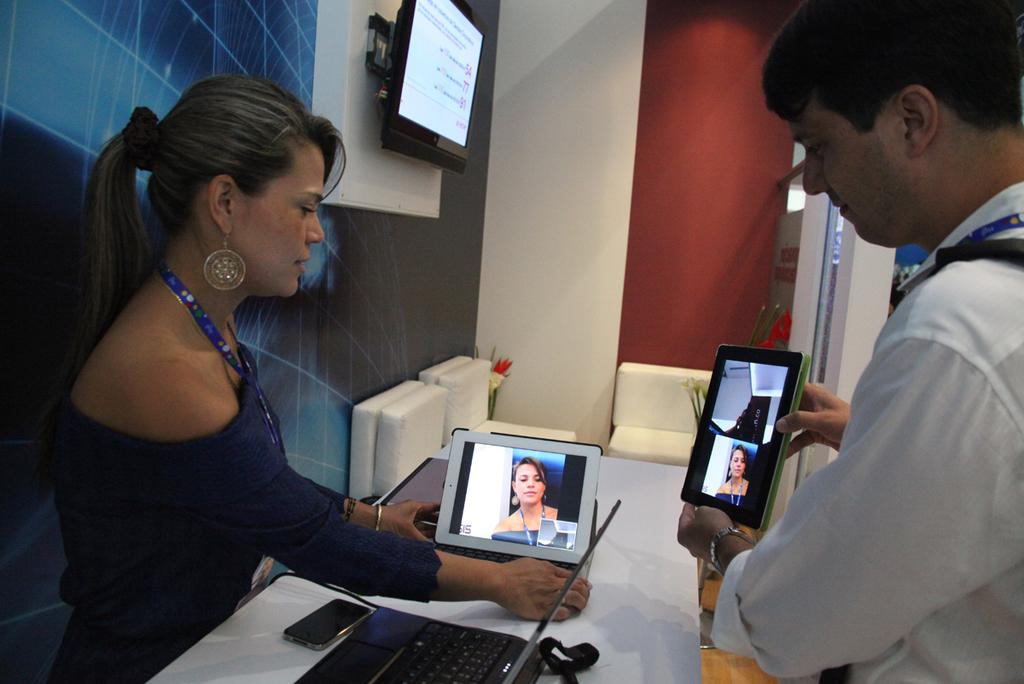How many people are present in the image? There is a woman and a man in the image. What objects can be seen on the table in the image? There is a laptop and a mobile on the table in the image. What type of electronic device is visible in the image? There are airpods in the image. What is the background of the image made of? There is a wall in the image. What is the rate of the doll's movement in the image? There is no doll present in the image, so it is not possible to determine the rate of its movement. How many hours does the screen display in the image? The image does not show the screen displaying any specific time or duration, so it is not possible to determine the number of hours. 